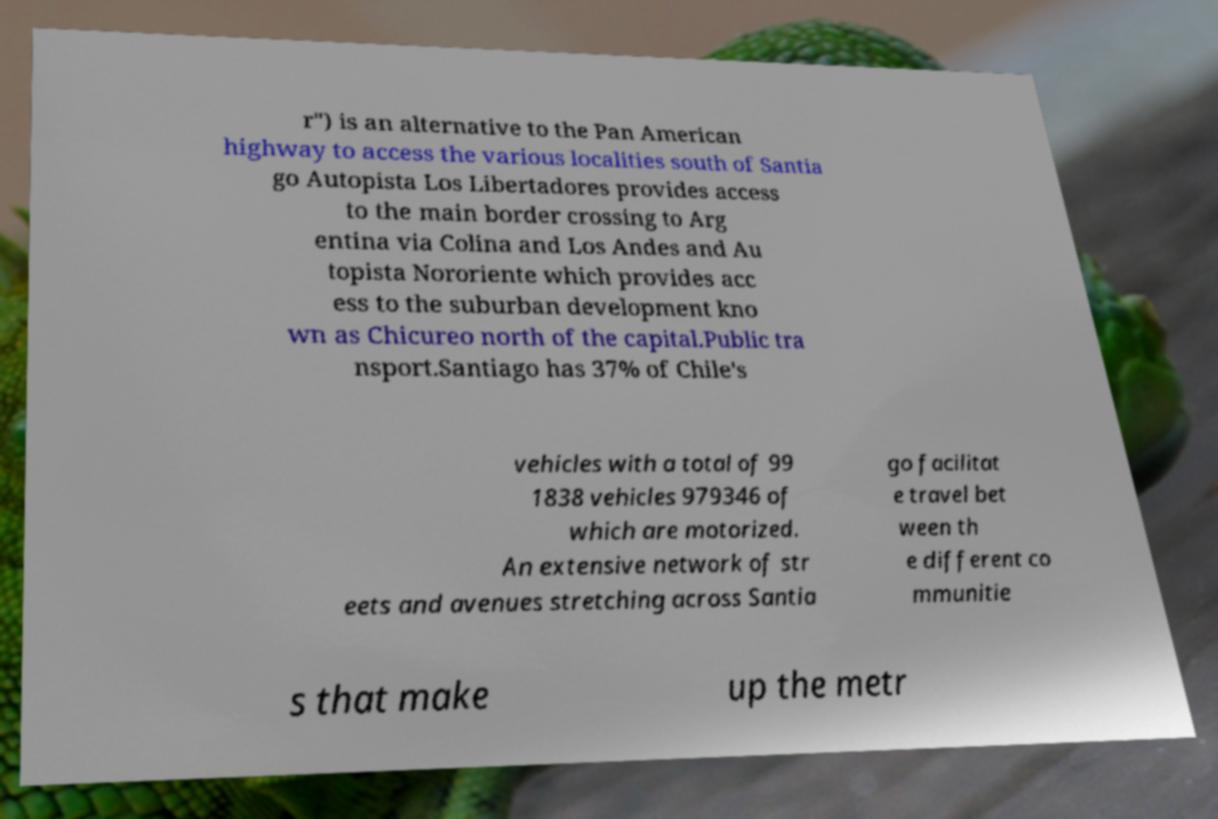Can you read and provide the text displayed in the image?This photo seems to have some interesting text. Can you extract and type it out for me? r") is an alternative to the Pan American highway to access the various localities south of Santia go Autopista Los Libertadores provides access to the main border crossing to Arg entina via Colina and Los Andes and Au topista Nororiente which provides acc ess to the suburban development kno wn as Chicureo north of the capital.Public tra nsport.Santiago has 37% of Chile's vehicles with a total of 99 1838 vehicles 979346 of which are motorized. An extensive network of str eets and avenues stretching across Santia go facilitat e travel bet ween th e different co mmunitie s that make up the metr 